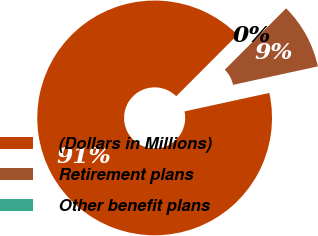<chart> <loc_0><loc_0><loc_500><loc_500><pie_chart><fcel>(Dollars in Millions)<fcel>Retirement plans<fcel>Other benefit plans<nl><fcel>90.9%<fcel>9.1%<fcel>0.01%<nl></chart> 